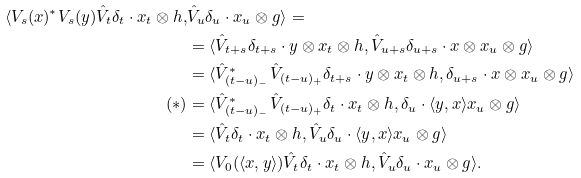<formula> <loc_0><loc_0><loc_500><loc_500>\langle V _ { s } ( x ) ^ { * } V _ { s } ( y ) \hat { V } _ { t } \delta _ { t } \cdot x _ { t } \otimes h , & \hat { V } _ { u } \delta _ { u } \cdot x _ { u } \otimes g \rangle = \\ & = \langle \hat { V } _ { t + s } \delta _ { t + s } \cdot y \otimes x _ { t } \otimes h , \hat { V } _ { u + s } \delta _ { u + s } \cdot x \otimes x _ { u } \otimes g \rangle \\ & = \langle \hat { V } _ { ( t - u ) _ { - } } ^ { * } \hat { V } _ { ( t - u ) _ { + } } \delta _ { t + s } \cdot y \otimes x _ { t } \otimes h , \delta _ { u + s } \cdot x \otimes x _ { u } \otimes g \rangle \\ ( * ) & = \langle \hat { V } _ { ( t - u ) _ { - } } ^ { * } \hat { V } _ { ( t - u ) _ { + } } \delta _ { t } \cdot x _ { t } \otimes h , \delta _ { u } \cdot \langle y , x \rangle x _ { u } \otimes g \rangle \\ & = \langle \hat { V } _ { t } \delta _ { t } \cdot x _ { t } \otimes h , \hat { V } _ { u } \delta _ { u } \cdot \langle y , x \rangle x _ { u } \otimes g \rangle \\ & = \langle V _ { 0 } ( \langle x , y \rangle ) \hat { V } _ { t } \delta _ { t } \cdot x _ { t } \otimes h , \hat { V } _ { u } \delta _ { u } \cdot x _ { u } \otimes g \rangle .</formula> 